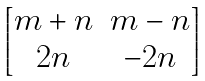<formula> <loc_0><loc_0><loc_500><loc_500>\begin{bmatrix} m + n & m - n \\ 2 n & - 2 n \end{bmatrix}</formula> 